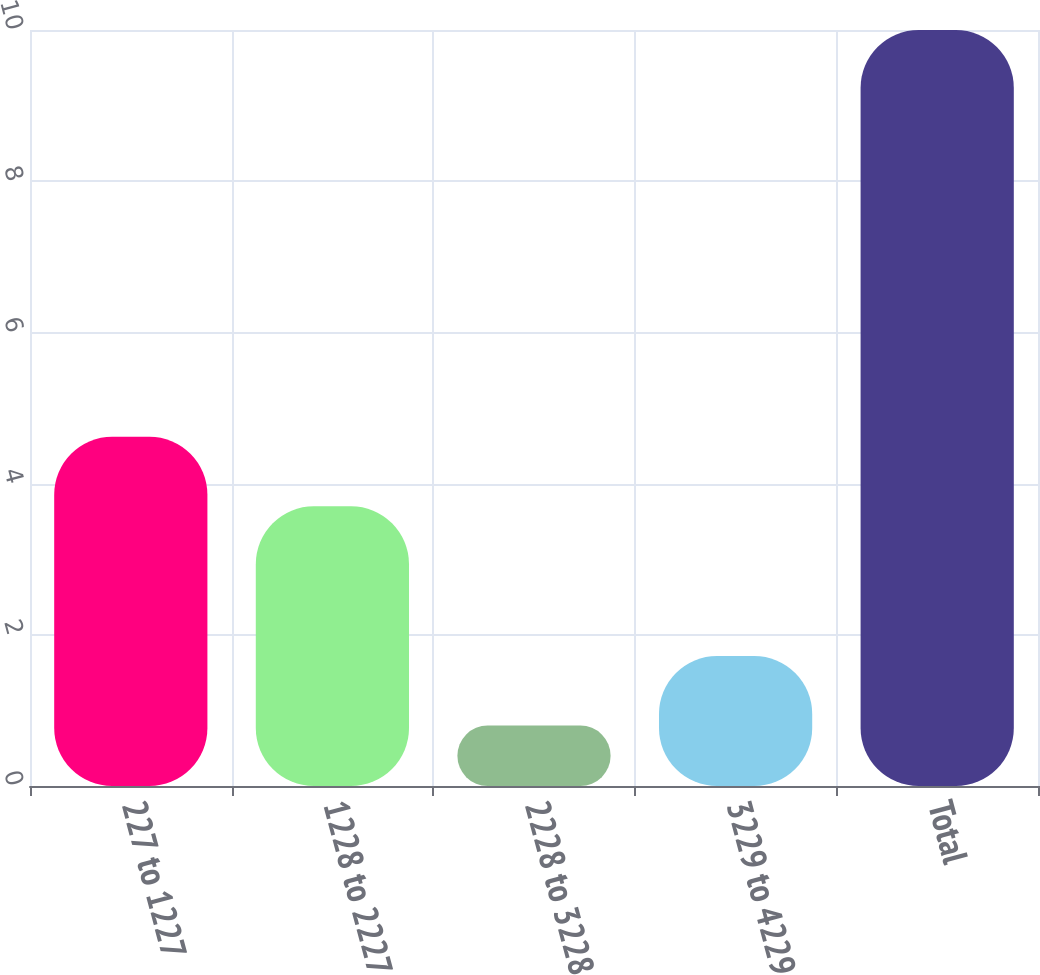<chart> <loc_0><loc_0><loc_500><loc_500><bar_chart><fcel>227 to 1227<fcel>1228 to 2227<fcel>2228 to 3228<fcel>3229 to 4229<fcel>Total<nl><fcel>4.62<fcel>3.7<fcel>0.8<fcel>1.72<fcel>10<nl></chart> 